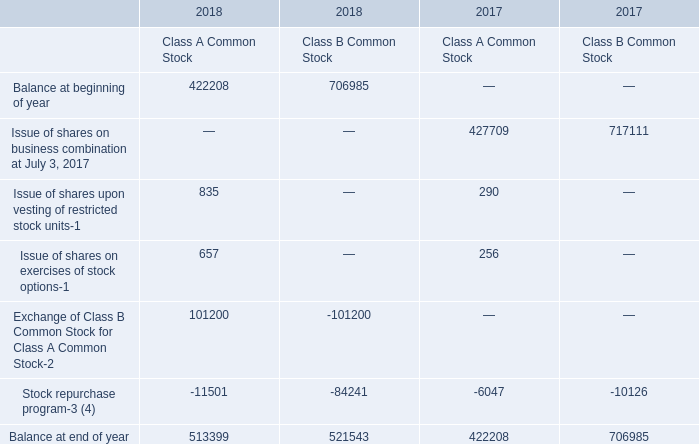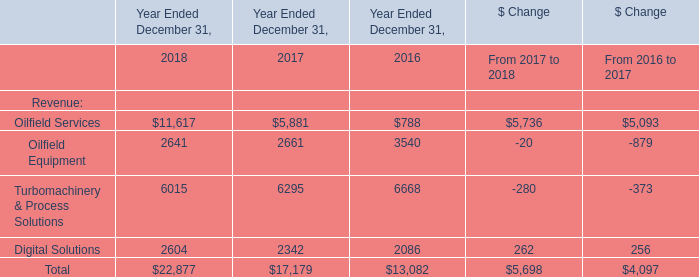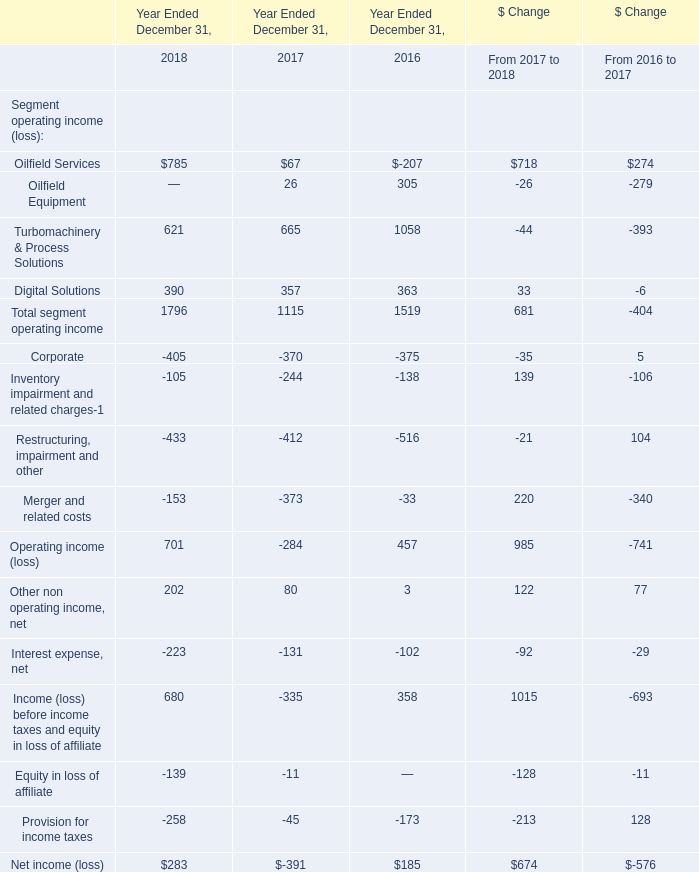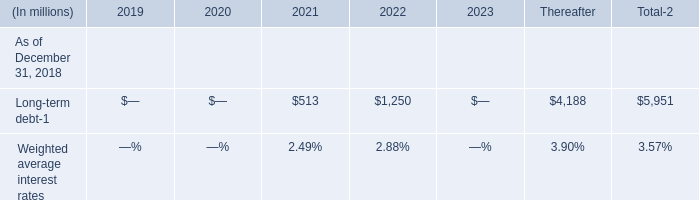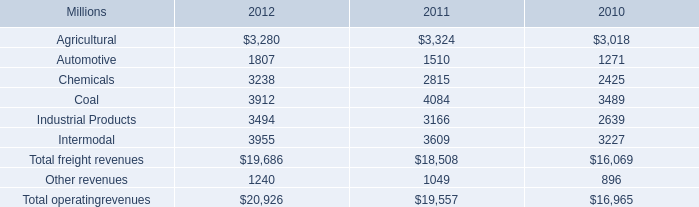What is the average amount of Digital Solutions of Year Ended December 31, 2017, and Stock repurchase program of 2018 Class B Common Stock ? 
Computations: ((2342.0 + 84241.0) / 2)
Answer: 43291.5. 